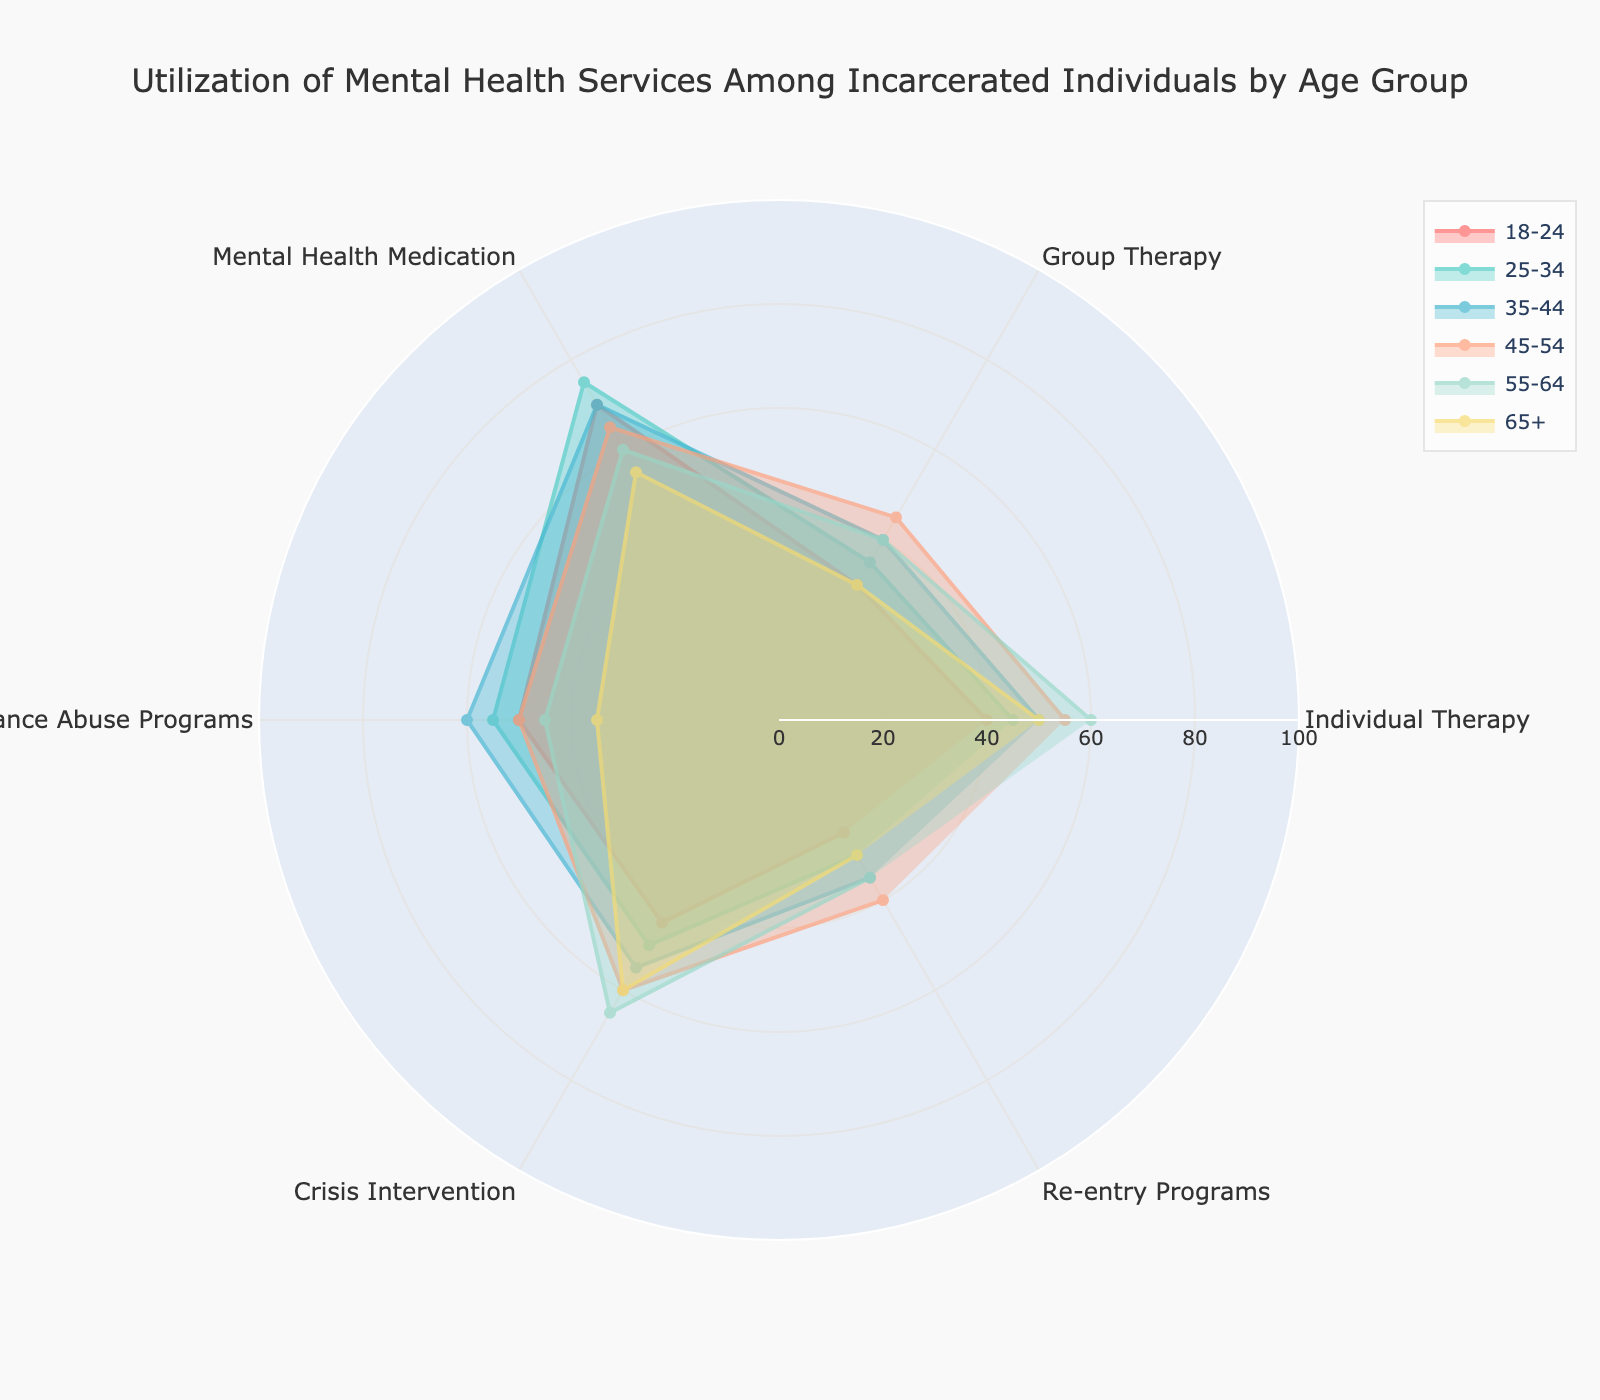What is the title of the radar chart? The title can be found at the top center of the radar chart. It indicates the main subject of the visual representation. The title is "Utilization of Mental Health Services Among Incarcerated Individuals by Age Group".
Answer: Utilization of Mental Health Services Among Incarcerated Individuals by Age Group Which age group has the highest utilization of individual therapy? To find the highest utilization of individual therapy, look for the age group with the longest line towards the "Individual Therapy" category. The age group 55-64 has the largest value at 60.
Answer: 55-64 Compare the utilization of mental health medication between the age groups 25-34 and 45-54. Which group has higher utilization? To compare, look at the points for "Mental Health Medication" for both age groups. The age group 25-34 has a utilization of 75, while the age group 45-54 has a utilization of 65. Therefore, the age group 25-34 has higher utilization.
Answer: 25-34 What are the two age groups with the lowest utilization rates for group therapy? Identify the shortest lines towards the "Group Therapy" category. The lowest values are for the 18-24 and 65+ age groups, both with a value of 30.
Answer: 18-24 and 65+ How does crisis intervention utilization vary across age groups? Review the "Crisis Intervention" points for all age groups. The utilization rates are 45 (18-24), 50 (25-34), 55 (35-44), 60 (45-54), 65 (55-64), and 60 (65+). The trend shows an increasing utilization with age, peaking at 65 for the 55-64 age group, before slightly decreasing.
Answer: Increasing with age, peaking at 55-64 What is the average utilization of re-entry programs across all age groups? To calculate the average, sum the values of re-entry programs across all age groups and divide by the number of age groups. The values are 25, 30, 35, 40, 35, and 30. Sum is 195. 195 divided by 6 is 32.5.
Answer: 32.5 Which service shows the most consistent utilization across all age groups? Consistency can be assessed by the smallest range of values across age groups. "Substance Abuse Programs" ranges from 35 to 60, whereas other services have a greater range. Therefore, "Substance Abuse Programs" shows the most consistent utilization.
Answer: Substance Abuse Programs Which age group has the least overall utilization of the mental health services measured? To determine the least overall utilization, we need to consider the average utilization across all services for each age group. By observation, the age group 65+ has relatively lower values across most categories compared to other age groups.
Answer: 65+ For the age group 45-54, which two services have almost similar utilization rates? Look at the values for the age group 45-54. The services "Individual Therapy" (55) and "Group Therapy" (45) have utilization rates that are close to each other.
Answer: Individual Therapy and Group Therapy Between the age groups 18-24 and 35-44, which group makes more use of substance abuse programs? Compare the values for "Substance Abuse Programs" for the two age groups. The age group 18-24 has a value of 50, while 35-44 has a value of 60. Therefore, 35-44 makes more use of substance abuse programs.
Answer: 35-44 